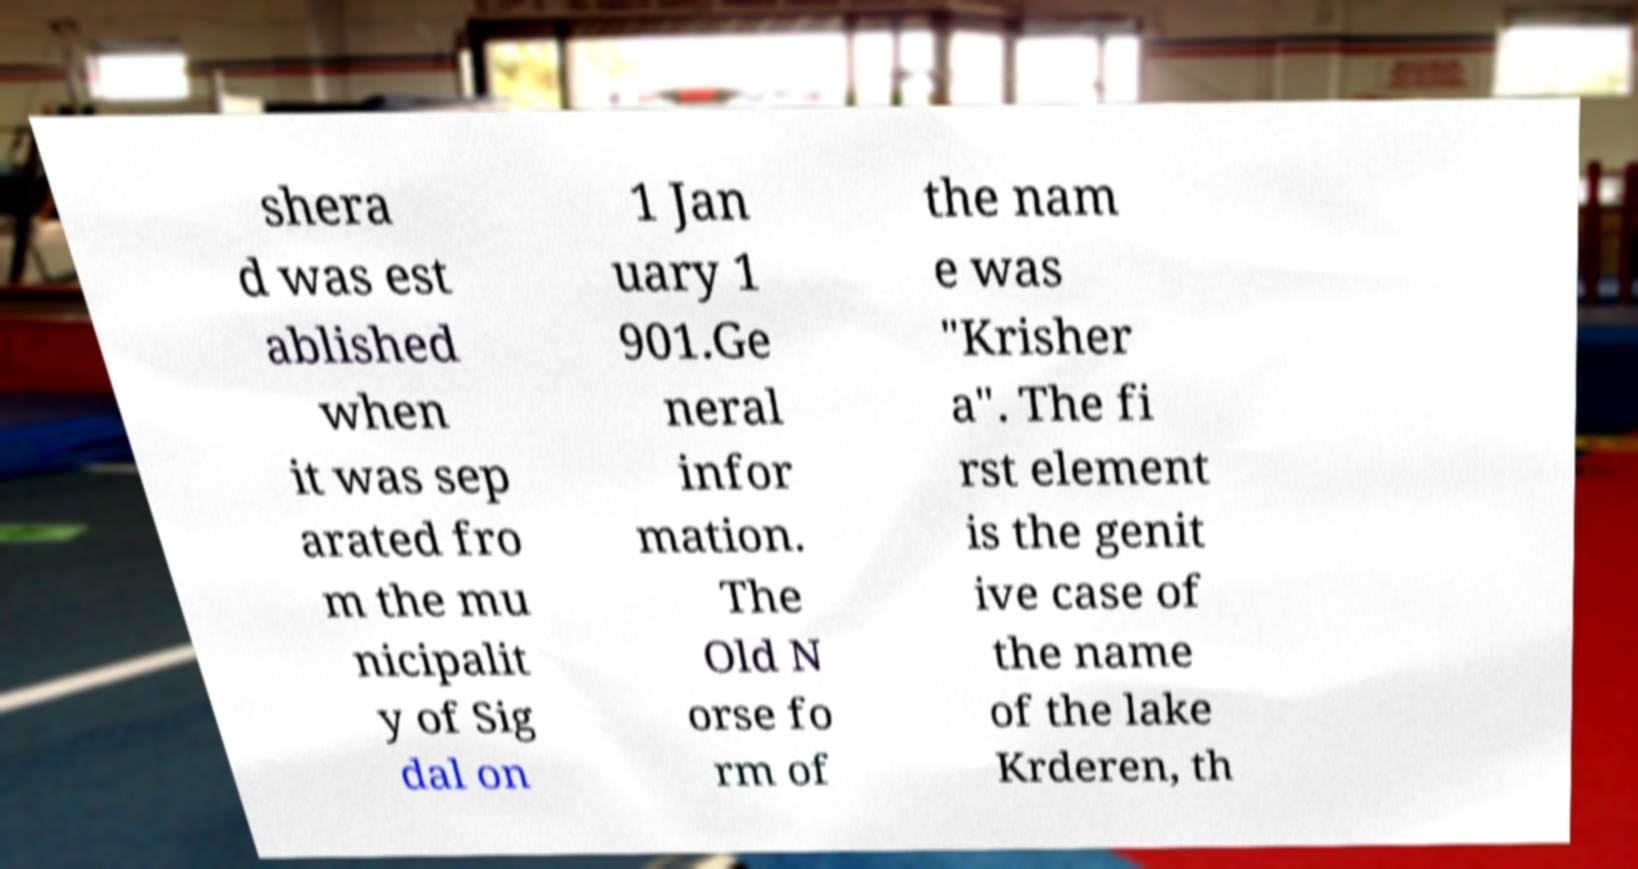Please read and relay the text visible in this image. What does it say? shera d was est ablished when it was sep arated fro m the mu nicipalit y of Sig dal on 1 Jan uary 1 901.Ge neral infor mation. The Old N orse fo rm of the nam e was "Krisher a". The fi rst element is the genit ive case of the name of the lake Krderen, th 